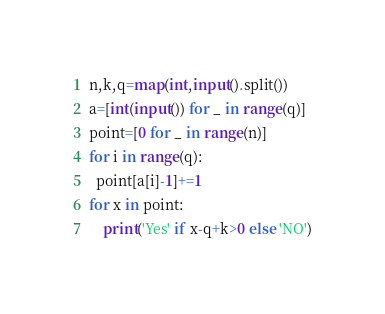<code> <loc_0><loc_0><loc_500><loc_500><_Python_>n,k,q=map(int,input().split())
a=[int(input()) for _ in range(q)]
point=[0 for _ in range(n)]
for i in range(q):
  point[a[i]-1]+=1
for x in point:
	print('Yes' if x-q+k>0 else 'NO')
</code> 